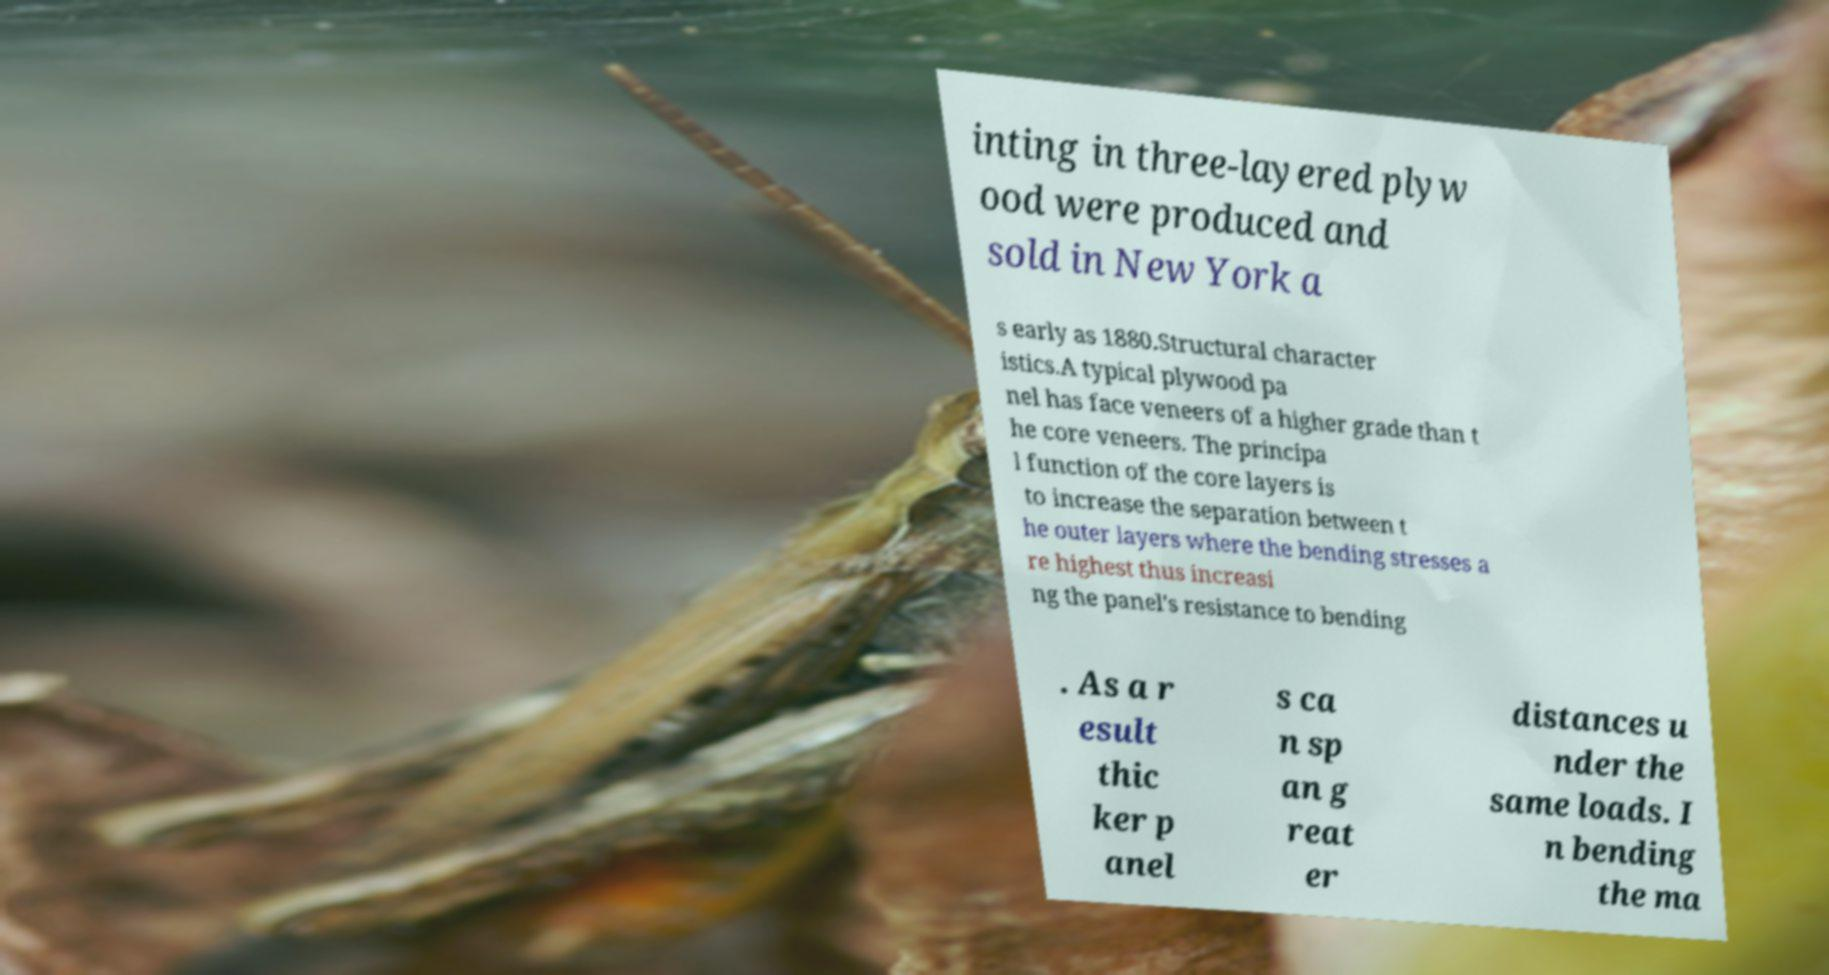Could you extract and type out the text from this image? inting in three-layered plyw ood were produced and sold in New York a s early as 1880.Structural character istics.A typical plywood pa nel has face veneers of a higher grade than t he core veneers. The principa l function of the core layers is to increase the separation between t he outer layers where the bending stresses a re highest thus increasi ng the panel's resistance to bending . As a r esult thic ker p anel s ca n sp an g reat er distances u nder the same loads. I n bending the ma 